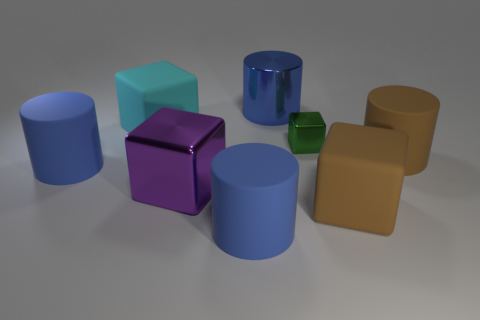Can you tell me which objects in the image are cubes and which are cylinders? Certainly! In the image, there are three objects that are cubes: a light teal cube, a purple cube, and a tiny green cube. The rest of the objects, which include two large blue cylinders, one smaller blue cylinder, and a brown cylinder, are all cylinders. 